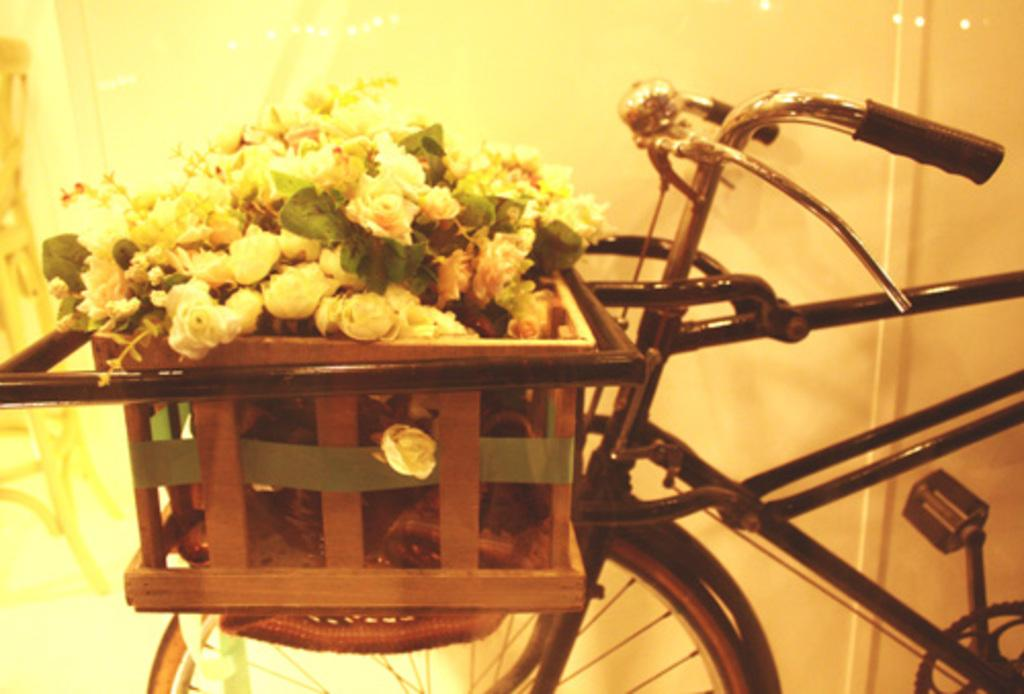What is the main object in the image? There is a bicycle in the image. What can be seen on the left side of the image? There are many flowers on the left side of the image. What type of pan is being used to cook the butter in the image? There is no pan or butter present in the image; it features a bicycle and flowers. 